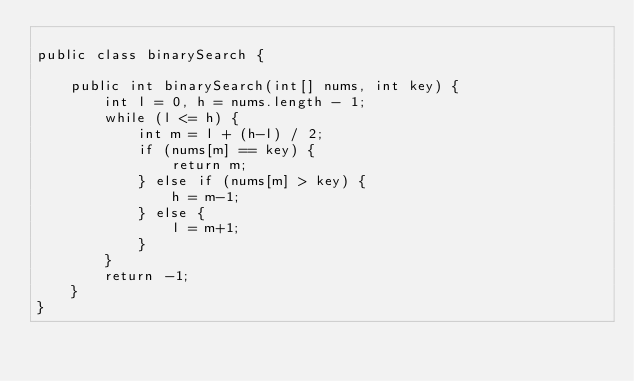<code> <loc_0><loc_0><loc_500><loc_500><_Java_>
public class binarySearch {

    public int binarySearch(int[] nums, int key) {
        int l = 0, h = nums.length - 1;
        while (l <= h) {
            int m = l + (h-l) / 2;
            if (nums[m] == key) {
                return m;
            } else if (nums[m] > key) {
                h = m-1;
            } else {
                l = m+1;
            }
        }
        return -1;
    }
}</code> 